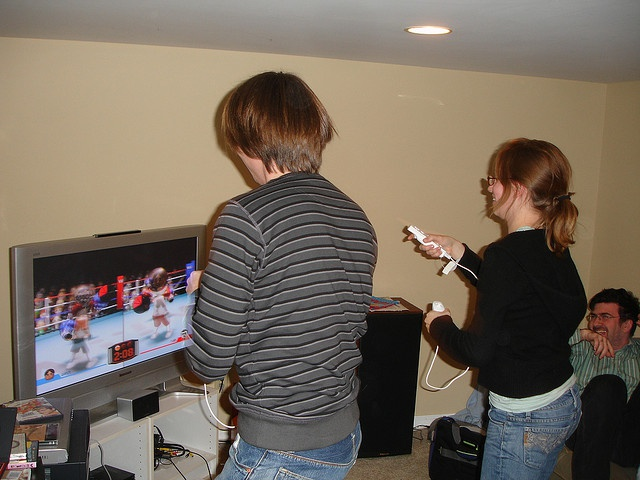Describe the objects in this image and their specific colors. I can see people in gray, black, maroon, and darkgray tones, people in gray, black, maroon, and tan tones, tv in gray, black, and darkgray tones, people in gray, black, and maroon tones, and remote in gray, white, darkgray, tan, and brown tones in this image. 